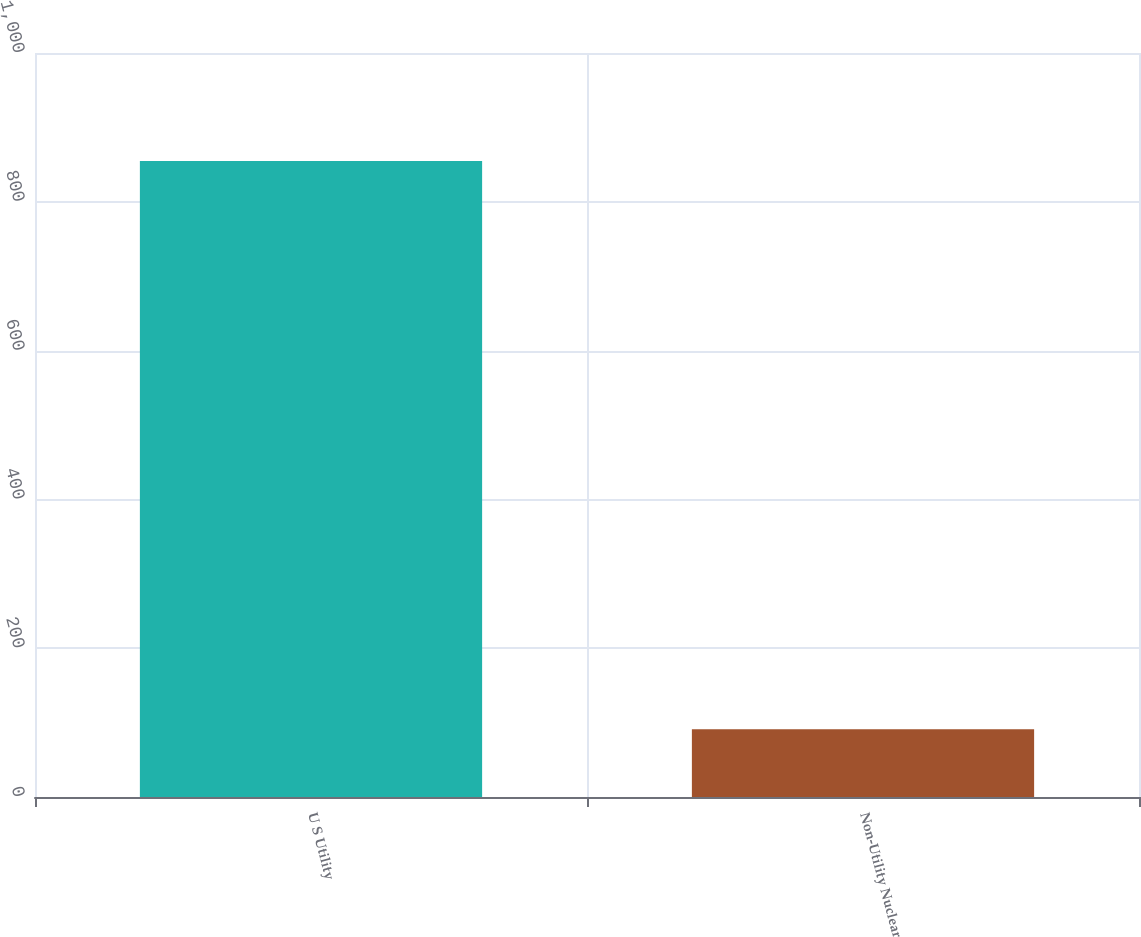Convert chart to OTSL. <chart><loc_0><loc_0><loc_500><loc_500><bar_chart><fcel>U S Utility<fcel>Non-Utility Nuclear<nl><fcel>855<fcel>91<nl></chart> 